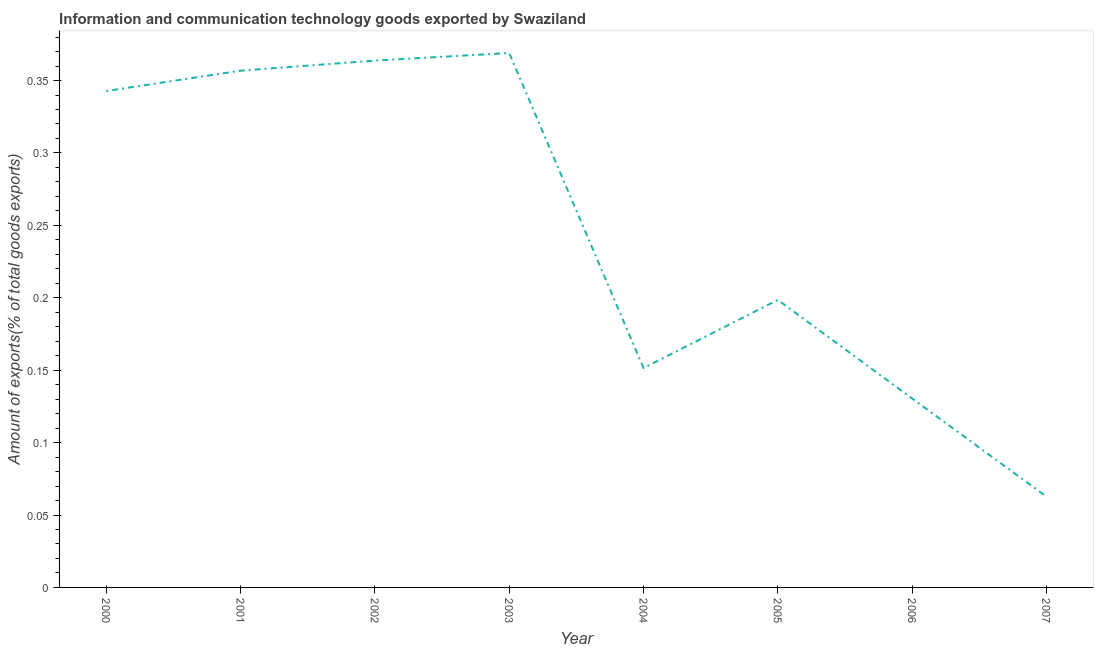What is the amount of ict goods exports in 2001?
Offer a terse response. 0.36. Across all years, what is the maximum amount of ict goods exports?
Offer a very short reply. 0.37. Across all years, what is the minimum amount of ict goods exports?
Keep it short and to the point. 0.06. In which year was the amount of ict goods exports maximum?
Provide a succinct answer. 2003. What is the sum of the amount of ict goods exports?
Make the answer very short. 1.98. What is the difference between the amount of ict goods exports in 2000 and 2004?
Your answer should be compact. 0.19. What is the average amount of ict goods exports per year?
Keep it short and to the point. 0.25. What is the median amount of ict goods exports?
Your response must be concise. 0.27. Do a majority of the years between 2005 and 2007 (inclusive) have amount of ict goods exports greater than 0.12000000000000001 %?
Make the answer very short. Yes. What is the ratio of the amount of ict goods exports in 2003 to that in 2005?
Provide a succinct answer. 1.86. Is the difference between the amount of ict goods exports in 2005 and 2007 greater than the difference between any two years?
Offer a very short reply. No. What is the difference between the highest and the second highest amount of ict goods exports?
Offer a terse response. 0.01. Is the sum of the amount of ict goods exports in 2000 and 2005 greater than the maximum amount of ict goods exports across all years?
Offer a very short reply. Yes. What is the difference between the highest and the lowest amount of ict goods exports?
Offer a terse response. 0.31. Does the amount of ict goods exports monotonically increase over the years?
Give a very brief answer. No. Are the values on the major ticks of Y-axis written in scientific E-notation?
Make the answer very short. No. What is the title of the graph?
Offer a very short reply. Information and communication technology goods exported by Swaziland. What is the label or title of the Y-axis?
Offer a terse response. Amount of exports(% of total goods exports). What is the Amount of exports(% of total goods exports) of 2000?
Make the answer very short. 0.34. What is the Amount of exports(% of total goods exports) of 2001?
Your answer should be very brief. 0.36. What is the Amount of exports(% of total goods exports) of 2002?
Keep it short and to the point. 0.36. What is the Amount of exports(% of total goods exports) in 2003?
Offer a terse response. 0.37. What is the Amount of exports(% of total goods exports) of 2004?
Keep it short and to the point. 0.15. What is the Amount of exports(% of total goods exports) in 2005?
Your response must be concise. 0.2. What is the Amount of exports(% of total goods exports) in 2006?
Your answer should be very brief. 0.13. What is the Amount of exports(% of total goods exports) of 2007?
Ensure brevity in your answer.  0.06. What is the difference between the Amount of exports(% of total goods exports) in 2000 and 2001?
Offer a terse response. -0.01. What is the difference between the Amount of exports(% of total goods exports) in 2000 and 2002?
Offer a very short reply. -0.02. What is the difference between the Amount of exports(% of total goods exports) in 2000 and 2003?
Your answer should be compact. -0.03. What is the difference between the Amount of exports(% of total goods exports) in 2000 and 2004?
Your answer should be very brief. 0.19. What is the difference between the Amount of exports(% of total goods exports) in 2000 and 2005?
Provide a short and direct response. 0.14. What is the difference between the Amount of exports(% of total goods exports) in 2000 and 2006?
Offer a very short reply. 0.21. What is the difference between the Amount of exports(% of total goods exports) in 2000 and 2007?
Provide a short and direct response. 0.28. What is the difference between the Amount of exports(% of total goods exports) in 2001 and 2002?
Your answer should be very brief. -0.01. What is the difference between the Amount of exports(% of total goods exports) in 2001 and 2003?
Your answer should be very brief. -0.01. What is the difference between the Amount of exports(% of total goods exports) in 2001 and 2004?
Ensure brevity in your answer.  0.21. What is the difference between the Amount of exports(% of total goods exports) in 2001 and 2005?
Offer a very short reply. 0.16. What is the difference between the Amount of exports(% of total goods exports) in 2001 and 2006?
Provide a succinct answer. 0.23. What is the difference between the Amount of exports(% of total goods exports) in 2001 and 2007?
Make the answer very short. 0.29. What is the difference between the Amount of exports(% of total goods exports) in 2002 and 2003?
Offer a terse response. -0.01. What is the difference between the Amount of exports(% of total goods exports) in 2002 and 2004?
Your response must be concise. 0.21. What is the difference between the Amount of exports(% of total goods exports) in 2002 and 2005?
Your answer should be very brief. 0.17. What is the difference between the Amount of exports(% of total goods exports) in 2002 and 2006?
Provide a succinct answer. 0.23. What is the difference between the Amount of exports(% of total goods exports) in 2002 and 2007?
Offer a terse response. 0.3. What is the difference between the Amount of exports(% of total goods exports) in 2003 and 2004?
Provide a short and direct response. 0.22. What is the difference between the Amount of exports(% of total goods exports) in 2003 and 2005?
Offer a very short reply. 0.17. What is the difference between the Amount of exports(% of total goods exports) in 2003 and 2006?
Ensure brevity in your answer.  0.24. What is the difference between the Amount of exports(% of total goods exports) in 2003 and 2007?
Your answer should be very brief. 0.31. What is the difference between the Amount of exports(% of total goods exports) in 2004 and 2005?
Give a very brief answer. -0.05. What is the difference between the Amount of exports(% of total goods exports) in 2004 and 2006?
Your answer should be very brief. 0.02. What is the difference between the Amount of exports(% of total goods exports) in 2004 and 2007?
Keep it short and to the point. 0.09. What is the difference between the Amount of exports(% of total goods exports) in 2005 and 2006?
Provide a short and direct response. 0.07. What is the difference between the Amount of exports(% of total goods exports) in 2005 and 2007?
Keep it short and to the point. 0.14. What is the difference between the Amount of exports(% of total goods exports) in 2006 and 2007?
Give a very brief answer. 0.07. What is the ratio of the Amount of exports(% of total goods exports) in 2000 to that in 2001?
Your answer should be compact. 0.96. What is the ratio of the Amount of exports(% of total goods exports) in 2000 to that in 2002?
Your response must be concise. 0.94. What is the ratio of the Amount of exports(% of total goods exports) in 2000 to that in 2003?
Offer a terse response. 0.93. What is the ratio of the Amount of exports(% of total goods exports) in 2000 to that in 2004?
Your answer should be compact. 2.26. What is the ratio of the Amount of exports(% of total goods exports) in 2000 to that in 2005?
Your answer should be very brief. 1.73. What is the ratio of the Amount of exports(% of total goods exports) in 2000 to that in 2006?
Your answer should be compact. 2.63. What is the ratio of the Amount of exports(% of total goods exports) in 2000 to that in 2007?
Provide a short and direct response. 5.47. What is the ratio of the Amount of exports(% of total goods exports) in 2001 to that in 2004?
Your answer should be compact. 2.36. What is the ratio of the Amount of exports(% of total goods exports) in 2001 to that in 2005?
Your answer should be compact. 1.8. What is the ratio of the Amount of exports(% of total goods exports) in 2001 to that in 2006?
Ensure brevity in your answer.  2.73. What is the ratio of the Amount of exports(% of total goods exports) in 2001 to that in 2007?
Give a very brief answer. 5.69. What is the ratio of the Amount of exports(% of total goods exports) in 2002 to that in 2003?
Ensure brevity in your answer.  0.99. What is the ratio of the Amount of exports(% of total goods exports) in 2002 to that in 2004?
Offer a very short reply. 2.4. What is the ratio of the Amount of exports(% of total goods exports) in 2002 to that in 2005?
Provide a succinct answer. 1.83. What is the ratio of the Amount of exports(% of total goods exports) in 2002 to that in 2006?
Provide a succinct answer. 2.79. What is the ratio of the Amount of exports(% of total goods exports) in 2002 to that in 2007?
Provide a short and direct response. 5.8. What is the ratio of the Amount of exports(% of total goods exports) in 2003 to that in 2004?
Make the answer very short. 2.44. What is the ratio of the Amount of exports(% of total goods exports) in 2003 to that in 2005?
Keep it short and to the point. 1.86. What is the ratio of the Amount of exports(% of total goods exports) in 2003 to that in 2006?
Give a very brief answer. 2.83. What is the ratio of the Amount of exports(% of total goods exports) in 2003 to that in 2007?
Provide a short and direct response. 5.88. What is the ratio of the Amount of exports(% of total goods exports) in 2004 to that in 2005?
Provide a succinct answer. 0.76. What is the ratio of the Amount of exports(% of total goods exports) in 2004 to that in 2006?
Your answer should be compact. 1.16. What is the ratio of the Amount of exports(% of total goods exports) in 2004 to that in 2007?
Ensure brevity in your answer.  2.42. What is the ratio of the Amount of exports(% of total goods exports) in 2005 to that in 2006?
Offer a very short reply. 1.52. What is the ratio of the Amount of exports(% of total goods exports) in 2005 to that in 2007?
Your answer should be very brief. 3.17. What is the ratio of the Amount of exports(% of total goods exports) in 2006 to that in 2007?
Offer a very short reply. 2.08. 